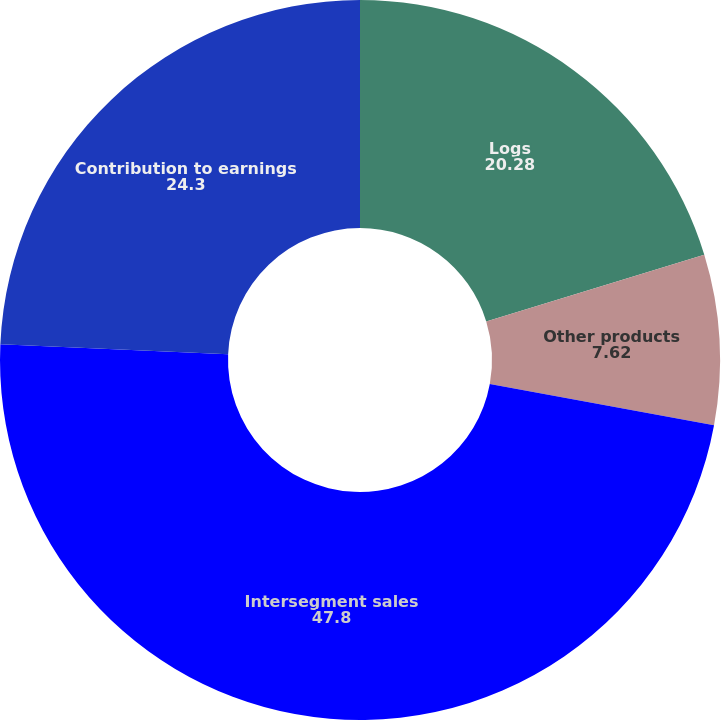Convert chart. <chart><loc_0><loc_0><loc_500><loc_500><pie_chart><fcel>Logs<fcel>Other products<fcel>Intersegment sales<fcel>Contribution to earnings<nl><fcel>20.28%<fcel>7.62%<fcel>47.8%<fcel>24.3%<nl></chart> 